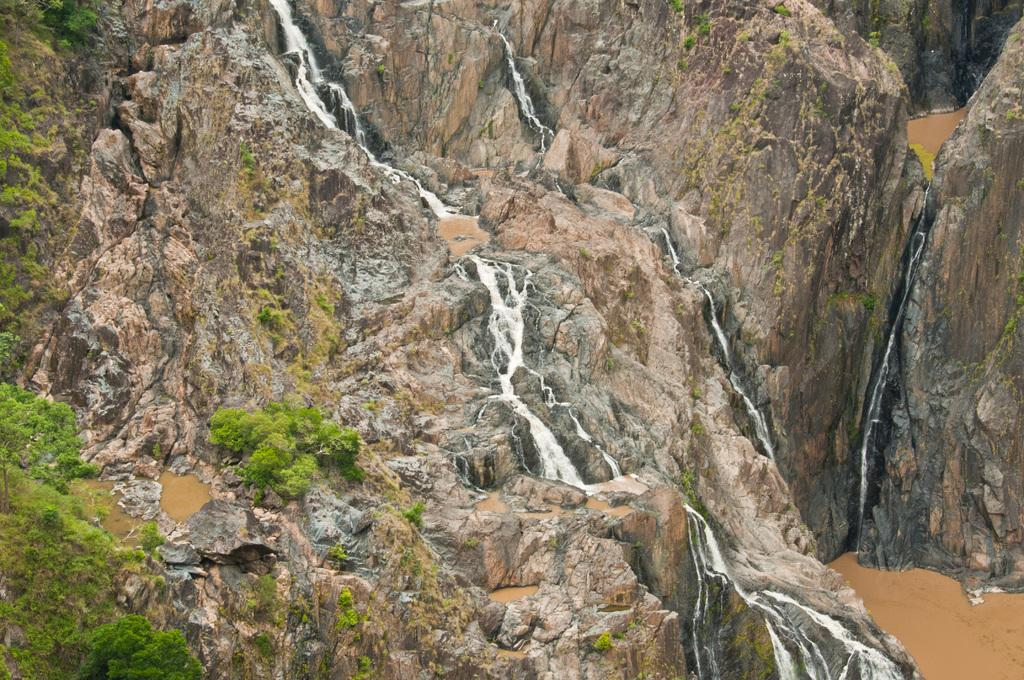What type of geographical feature is present in the image? There is a valley in the image. What is happening with the water in the image? Water is flowing through hills in the image. Where does the water flow in the image? The water flows into the valley. What type of trick can be seen being performed with the plastic in the image? There is no plastic present in the image, and therefore no trick can be observed. How intense is the rainstorm in the image? There is no rainstorm present in the image; it features a valley and water flowing through hills. 